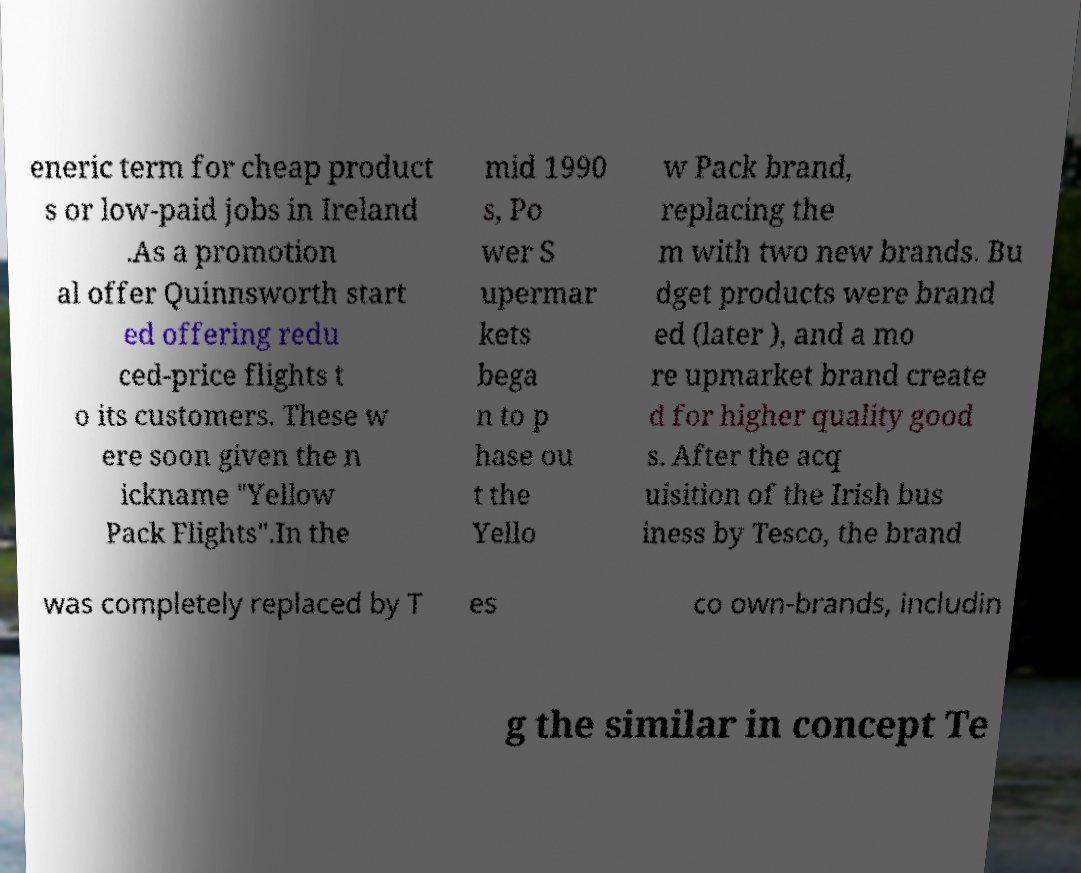For documentation purposes, I need the text within this image transcribed. Could you provide that? eneric term for cheap product s or low-paid jobs in Ireland .As a promotion al offer Quinnsworth start ed offering redu ced-price flights t o its customers. These w ere soon given the n ickname "Yellow Pack Flights".In the mid 1990 s, Po wer S upermar kets bega n to p hase ou t the Yello w Pack brand, replacing the m with two new brands. Bu dget products were brand ed (later ), and a mo re upmarket brand create d for higher quality good s. After the acq uisition of the Irish bus iness by Tesco, the brand was completely replaced by T es co own-brands, includin g the similar in concept Te 